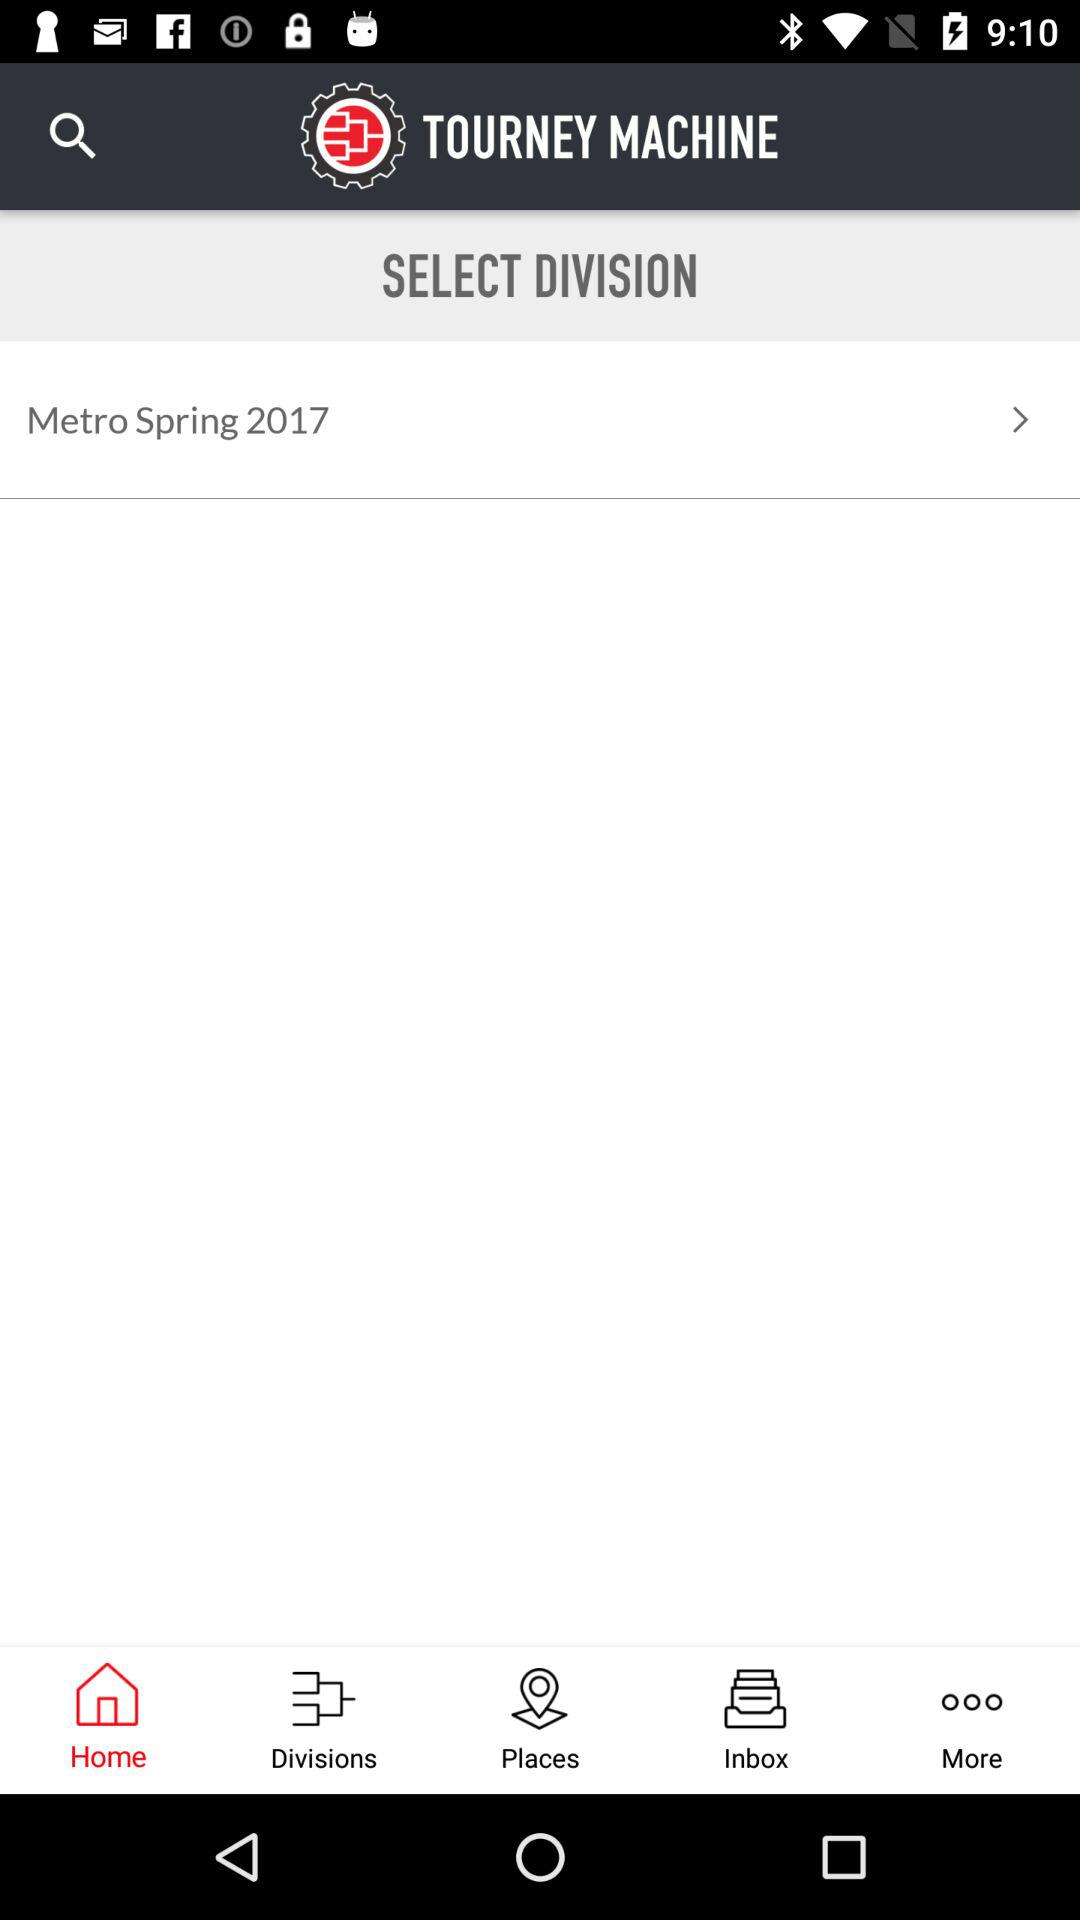What is the application name? The application name is "TOURNEY MACHINE". 